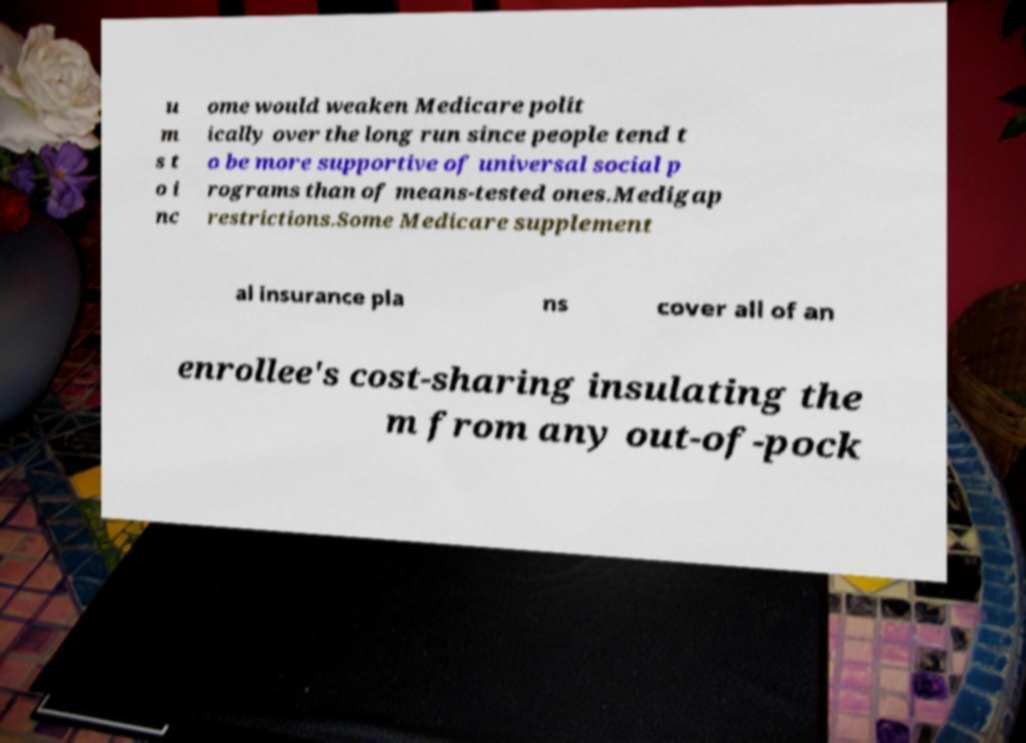What messages or text are displayed in this image? I need them in a readable, typed format. u m s t o i nc ome would weaken Medicare polit ically over the long run since people tend t o be more supportive of universal social p rograms than of means-tested ones.Medigap restrictions.Some Medicare supplement al insurance pla ns cover all of an enrollee's cost-sharing insulating the m from any out-of-pock 